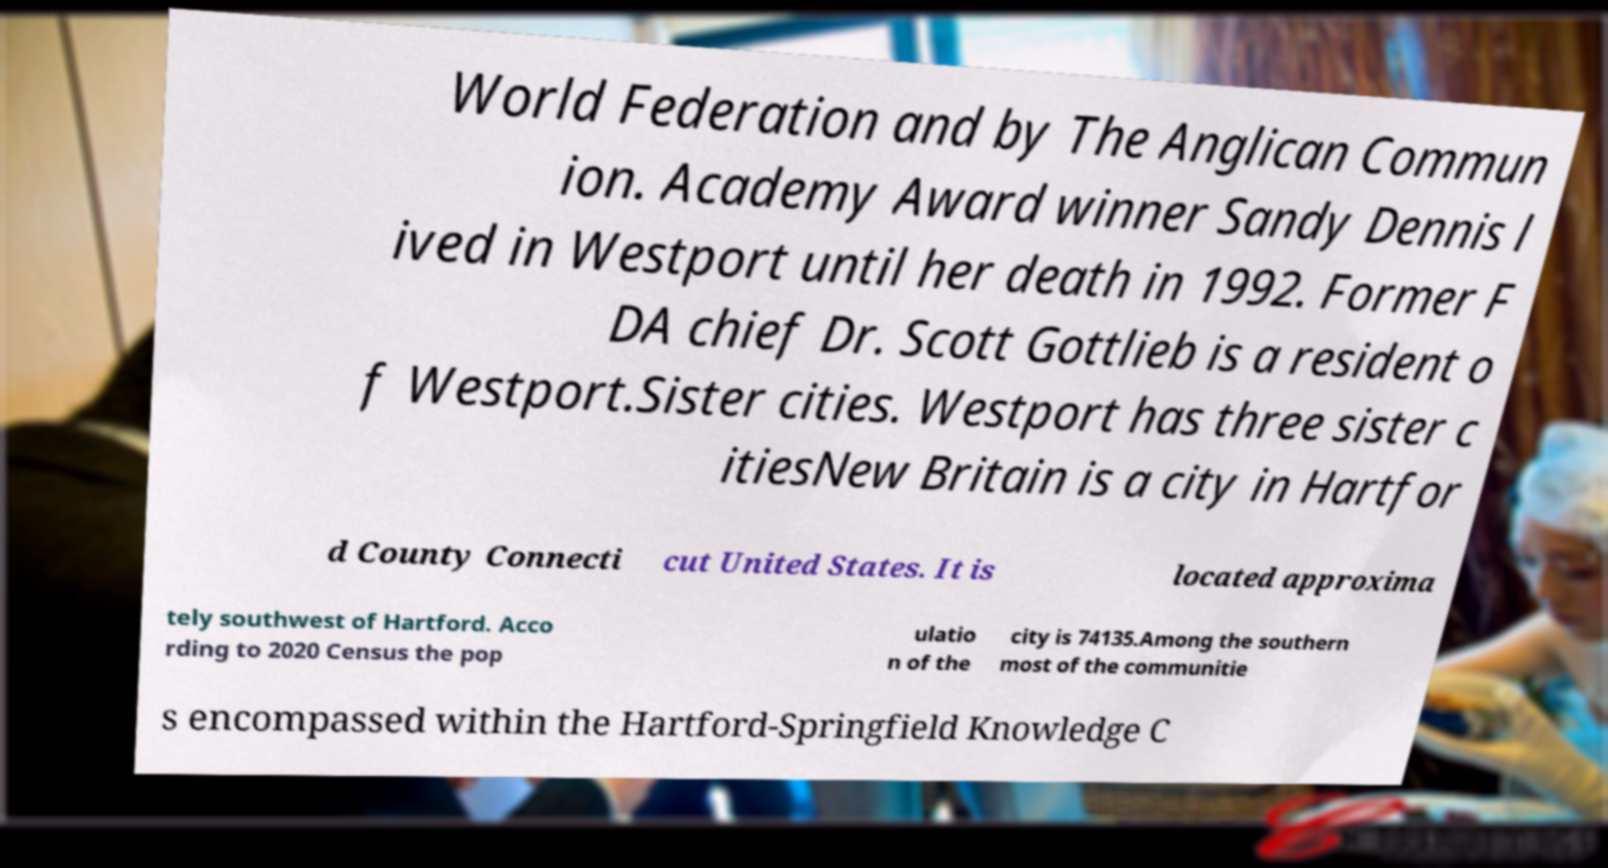Can you accurately transcribe the text from the provided image for me? World Federation and by The Anglican Commun ion. Academy Award winner Sandy Dennis l ived in Westport until her death in 1992. Former F DA chief Dr. Scott Gottlieb is a resident o f Westport.Sister cities. Westport has three sister c itiesNew Britain is a city in Hartfor d County Connecti cut United States. It is located approxima tely southwest of Hartford. Acco rding to 2020 Census the pop ulatio n of the city is 74135.Among the southern most of the communitie s encompassed within the Hartford-Springfield Knowledge C 